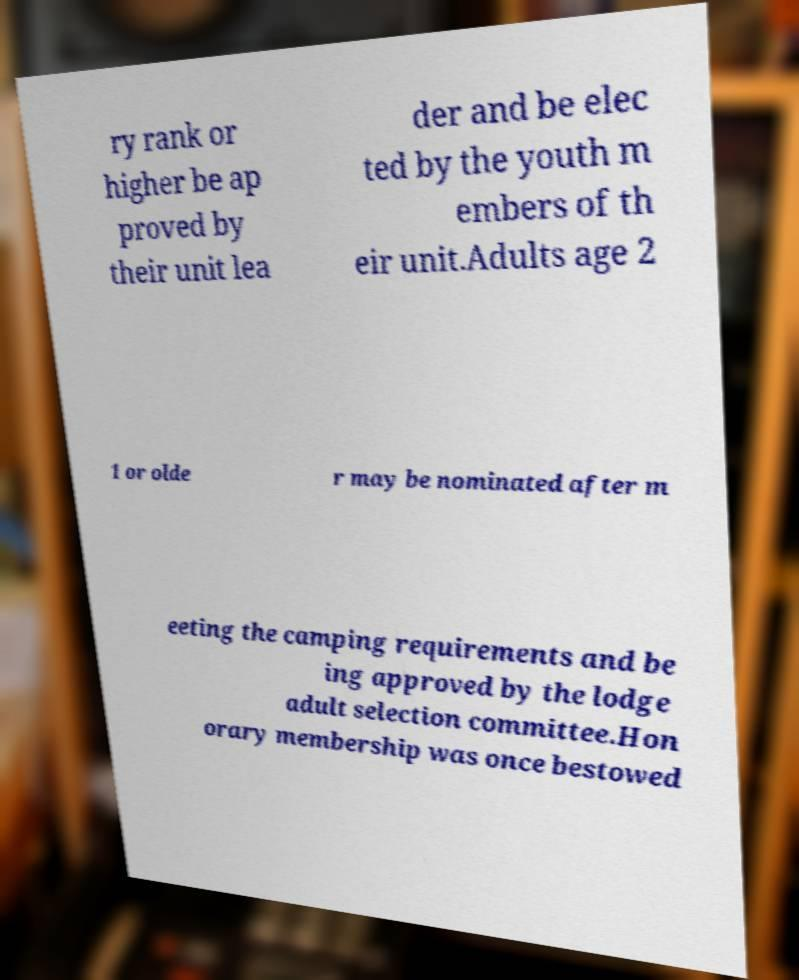Please read and relay the text visible in this image. What does it say? ry rank or higher be ap proved by their unit lea der and be elec ted by the youth m embers of th eir unit.Adults age 2 1 or olde r may be nominated after m eeting the camping requirements and be ing approved by the lodge adult selection committee.Hon orary membership was once bestowed 